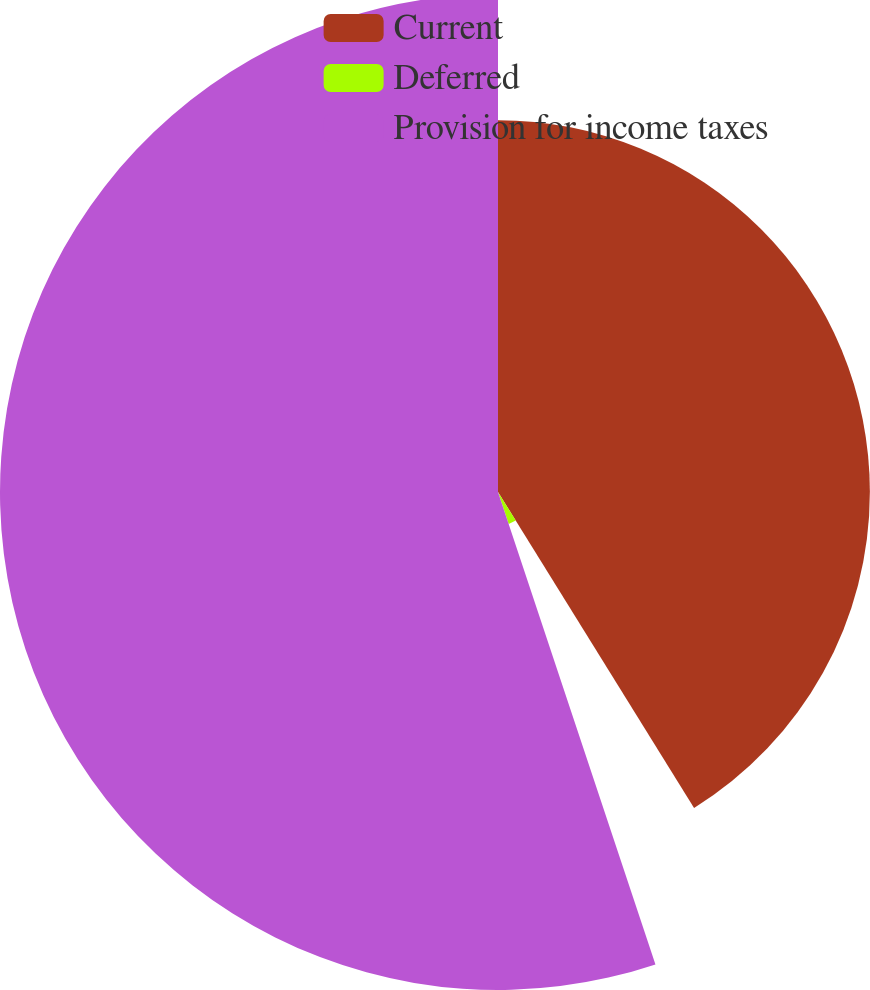Convert chart. <chart><loc_0><loc_0><loc_500><loc_500><pie_chart><fcel>Current<fcel>Deferred<fcel>Provision for income taxes<nl><fcel>41.16%<fcel>3.72%<fcel>55.12%<nl></chart> 